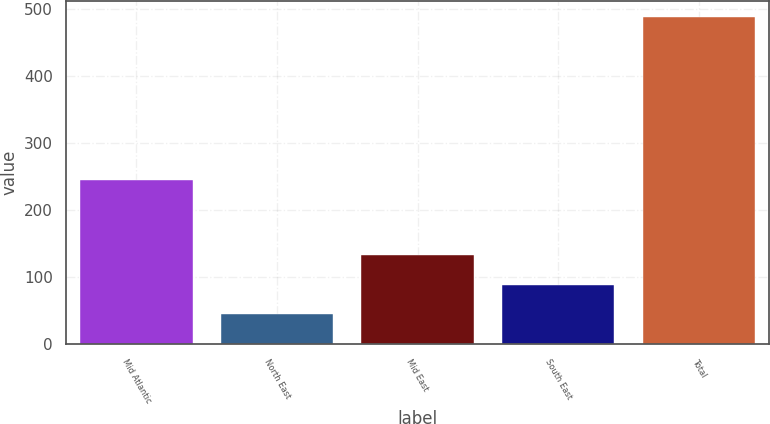Convert chart. <chart><loc_0><loc_0><loc_500><loc_500><bar_chart><fcel>Mid Atlantic<fcel>North East<fcel>Mid East<fcel>South East<fcel>Total<nl><fcel>245<fcel>44<fcel>132.8<fcel>88.4<fcel>488<nl></chart> 